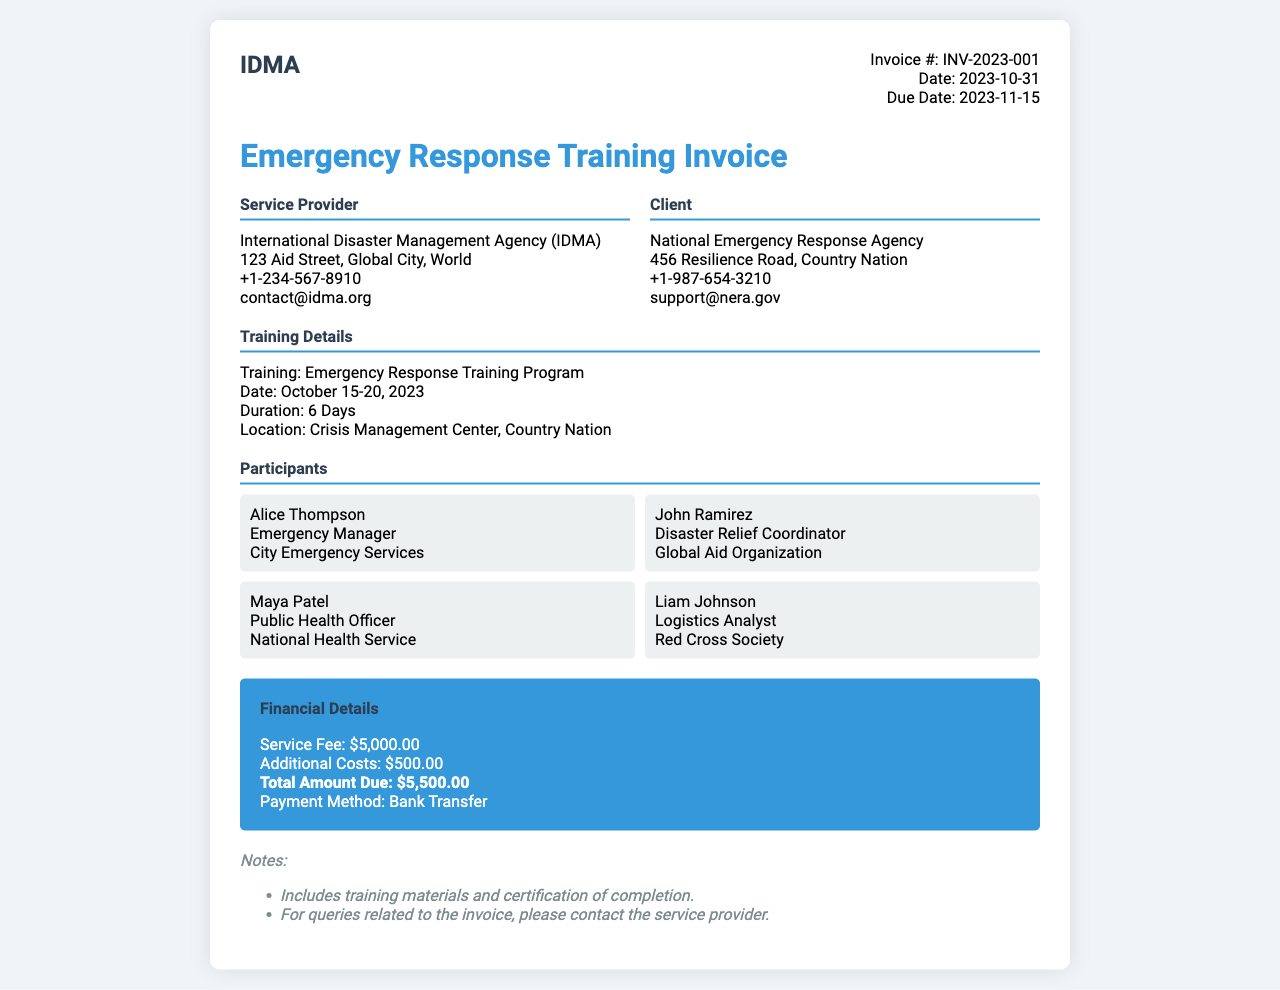What is the invoice number? The invoice number is clearly stated in the document, which is INV-2023-001.
Answer: INV-2023-001 Who is the service provider? The service provider is mentioned in the document as the International Disaster Management Agency (IDMA).
Answer: International Disaster Management Agency (IDMA) What is the total amount due? The total amount due is specified in the financial details section as $5,500.00.
Answer: $5,500.00 When did the training occur? The training dates are indicated in the training details section, which is October 15-20, 2023.
Answer: October 15-20, 2023 How many participants were there? Counting the participants listed in the document, there are a total of four participants.
Answer: 4 What was the duration of the training? The duration of the training is detailed in the document, listed as 6 days.
Answer: 6 Days What is the payment method? The payment method is mentioned in the financial details section, noted as Bank Transfer.
Answer: Bank Transfer Which organization did Alice Thompson represent? The document specifies that Alice Thompson is from City Emergency Services.
Answer: City Emergency Services What additional costs are mentioned? The document outlines the additional costs as $500.00.
Answer: $500.00 